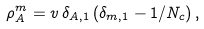<formula> <loc_0><loc_0><loc_500><loc_500>\rho _ { A } ^ { m } = v \, \delta _ { A , 1 } \, ( \delta _ { m , 1 } - 1 / N _ { c } ) \, ,</formula> 